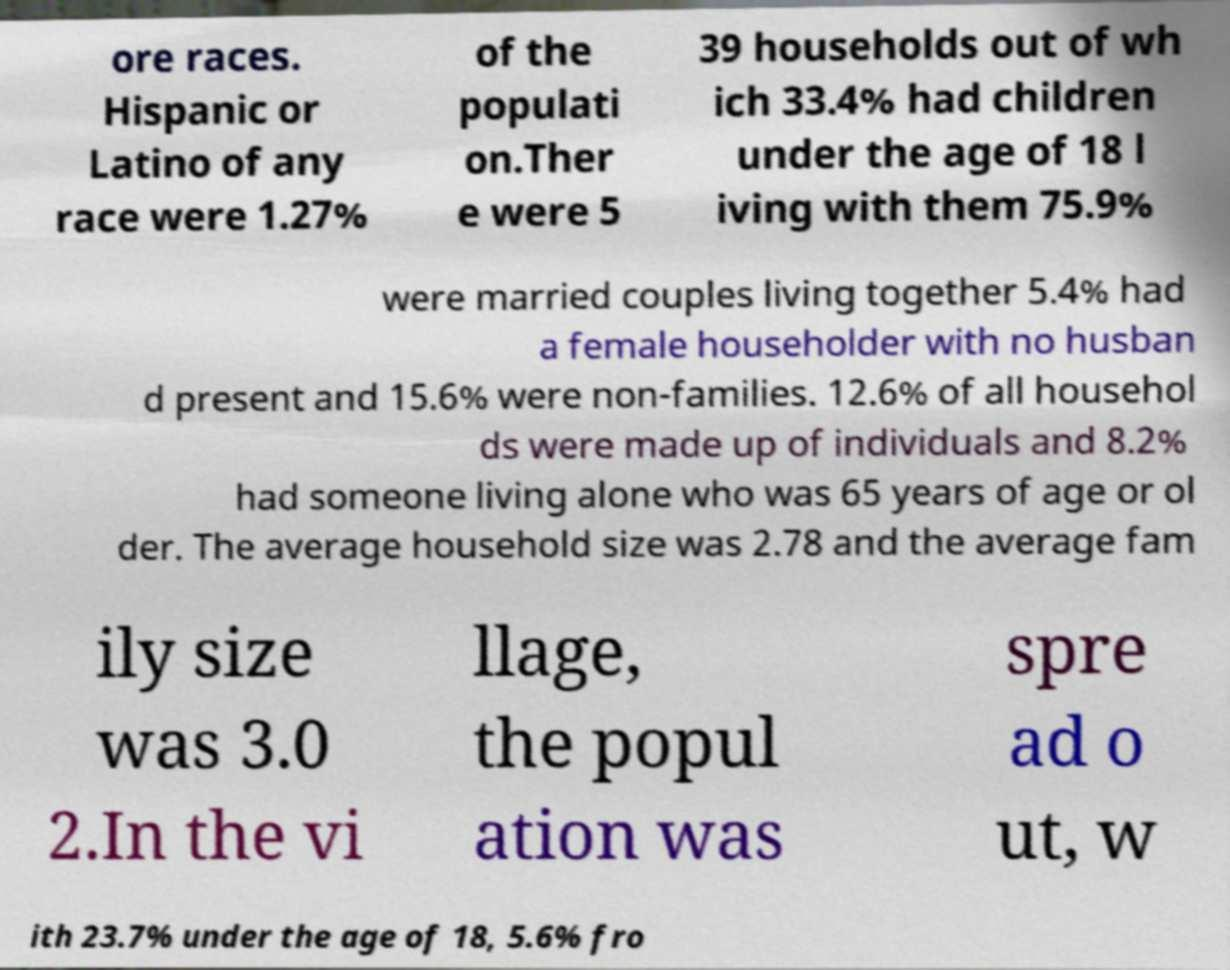Could you extract and type out the text from this image? ore races. Hispanic or Latino of any race were 1.27% of the populati on.Ther e were 5 39 households out of wh ich 33.4% had children under the age of 18 l iving with them 75.9% were married couples living together 5.4% had a female householder with no husban d present and 15.6% were non-families. 12.6% of all househol ds were made up of individuals and 8.2% had someone living alone who was 65 years of age or ol der. The average household size was 2.78 and the average fam ily size was 3.0 2.In the vi llage, the popul ation was spre ad o ut, w ith 23.7% under the age of 18, 5.6% fro 